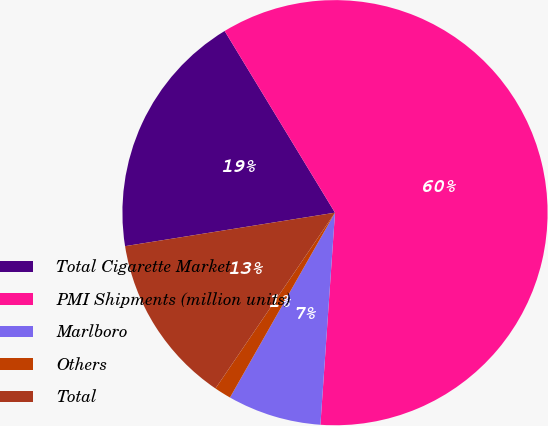Convert chart to OTSL. <chart><loc_0><loc_0><loc_500><loc_500><pie_chart><fcel>Total Cigarette Market<fcel>PMI Shipments (million units)<fcel>Marlboro<fcel>Others<fcel>Total<nl><fcel>18.83%<fcel>59.78%<fcel>7.13%<fcel>1.28%<fcel>12.98%<nl></chart> 